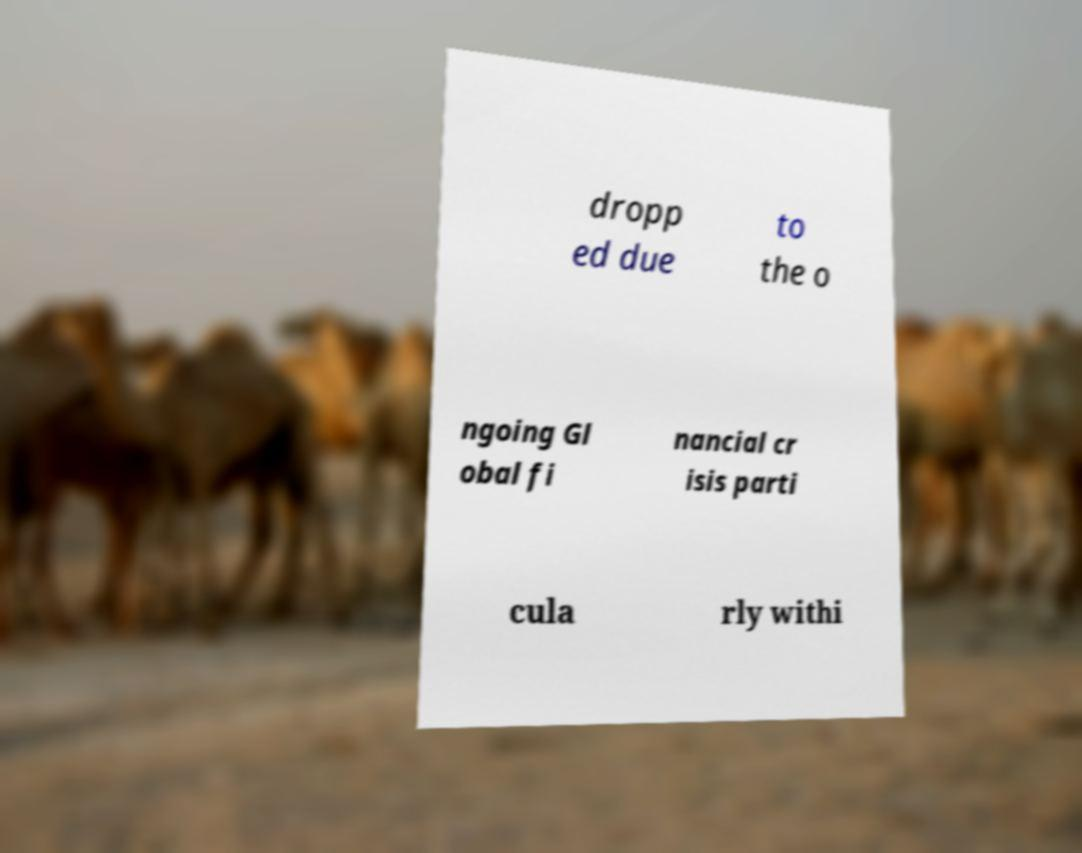For documentation purposes, I need the text within this image transcribed. Could you provide that? dropp ed due to the o ngoing Gl obal fi nancial cr isis parti cula rly withi 